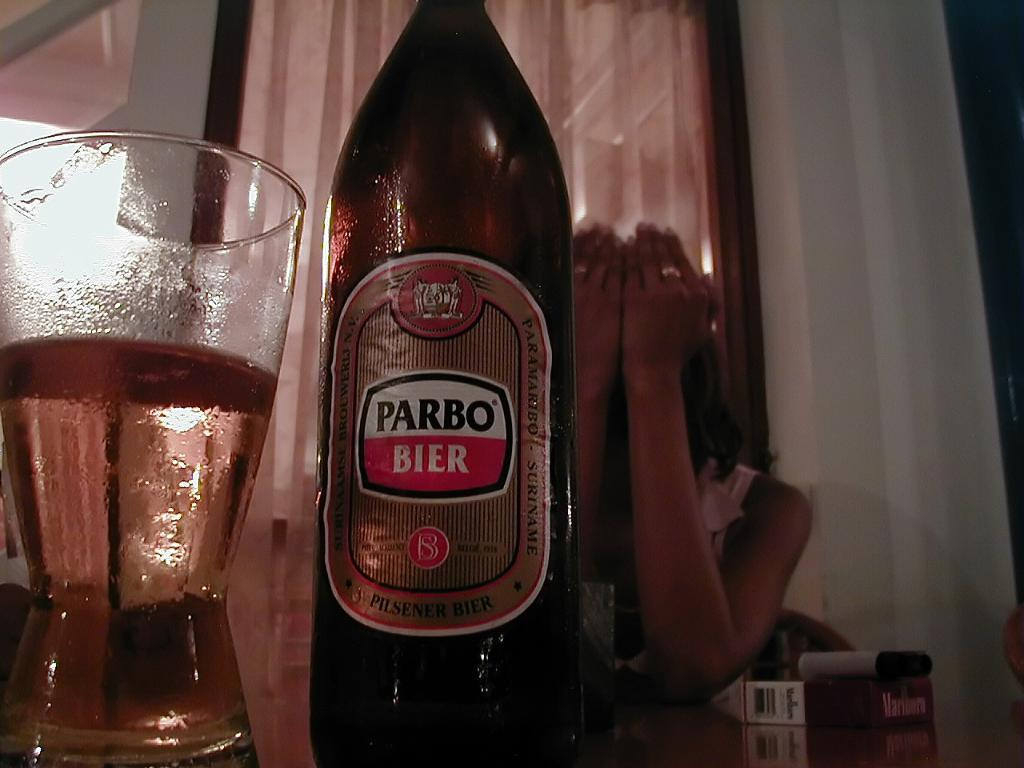What piece of furniture is present in the image? There is a table in the image. What is on the table? There is a bear bottle and a glass on the table. Can you describe the woman's position in the image? There is a woman sitting on a chair in the background. What is behind the woman? There is a wall behind the woman. Is there a map on the table in the image? No, there is no map present on the table in the image. 